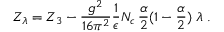<formula> <loc_0><loc_0><loc_500><loc_500>Z _ { \lambda } = Z _ { 3 } - \frac { g ^ { 2 } } { 1 6 \pi ^ { 2 } } \frac { 1 } { \epsilon } N _ { c } \, \frac { \alpha } { 2 } ( 1 - \frac { \alpha } { 2 } ) \, \lambda \, .</formula> 